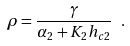Convert formula to latex. <formula><loc_0><loc_0><loc_500><loc_500>\rho = \frac { \gamma } { \alpha _ { 2 } + K _ { 2 } h _ { c 2 } } \ .</formula> 